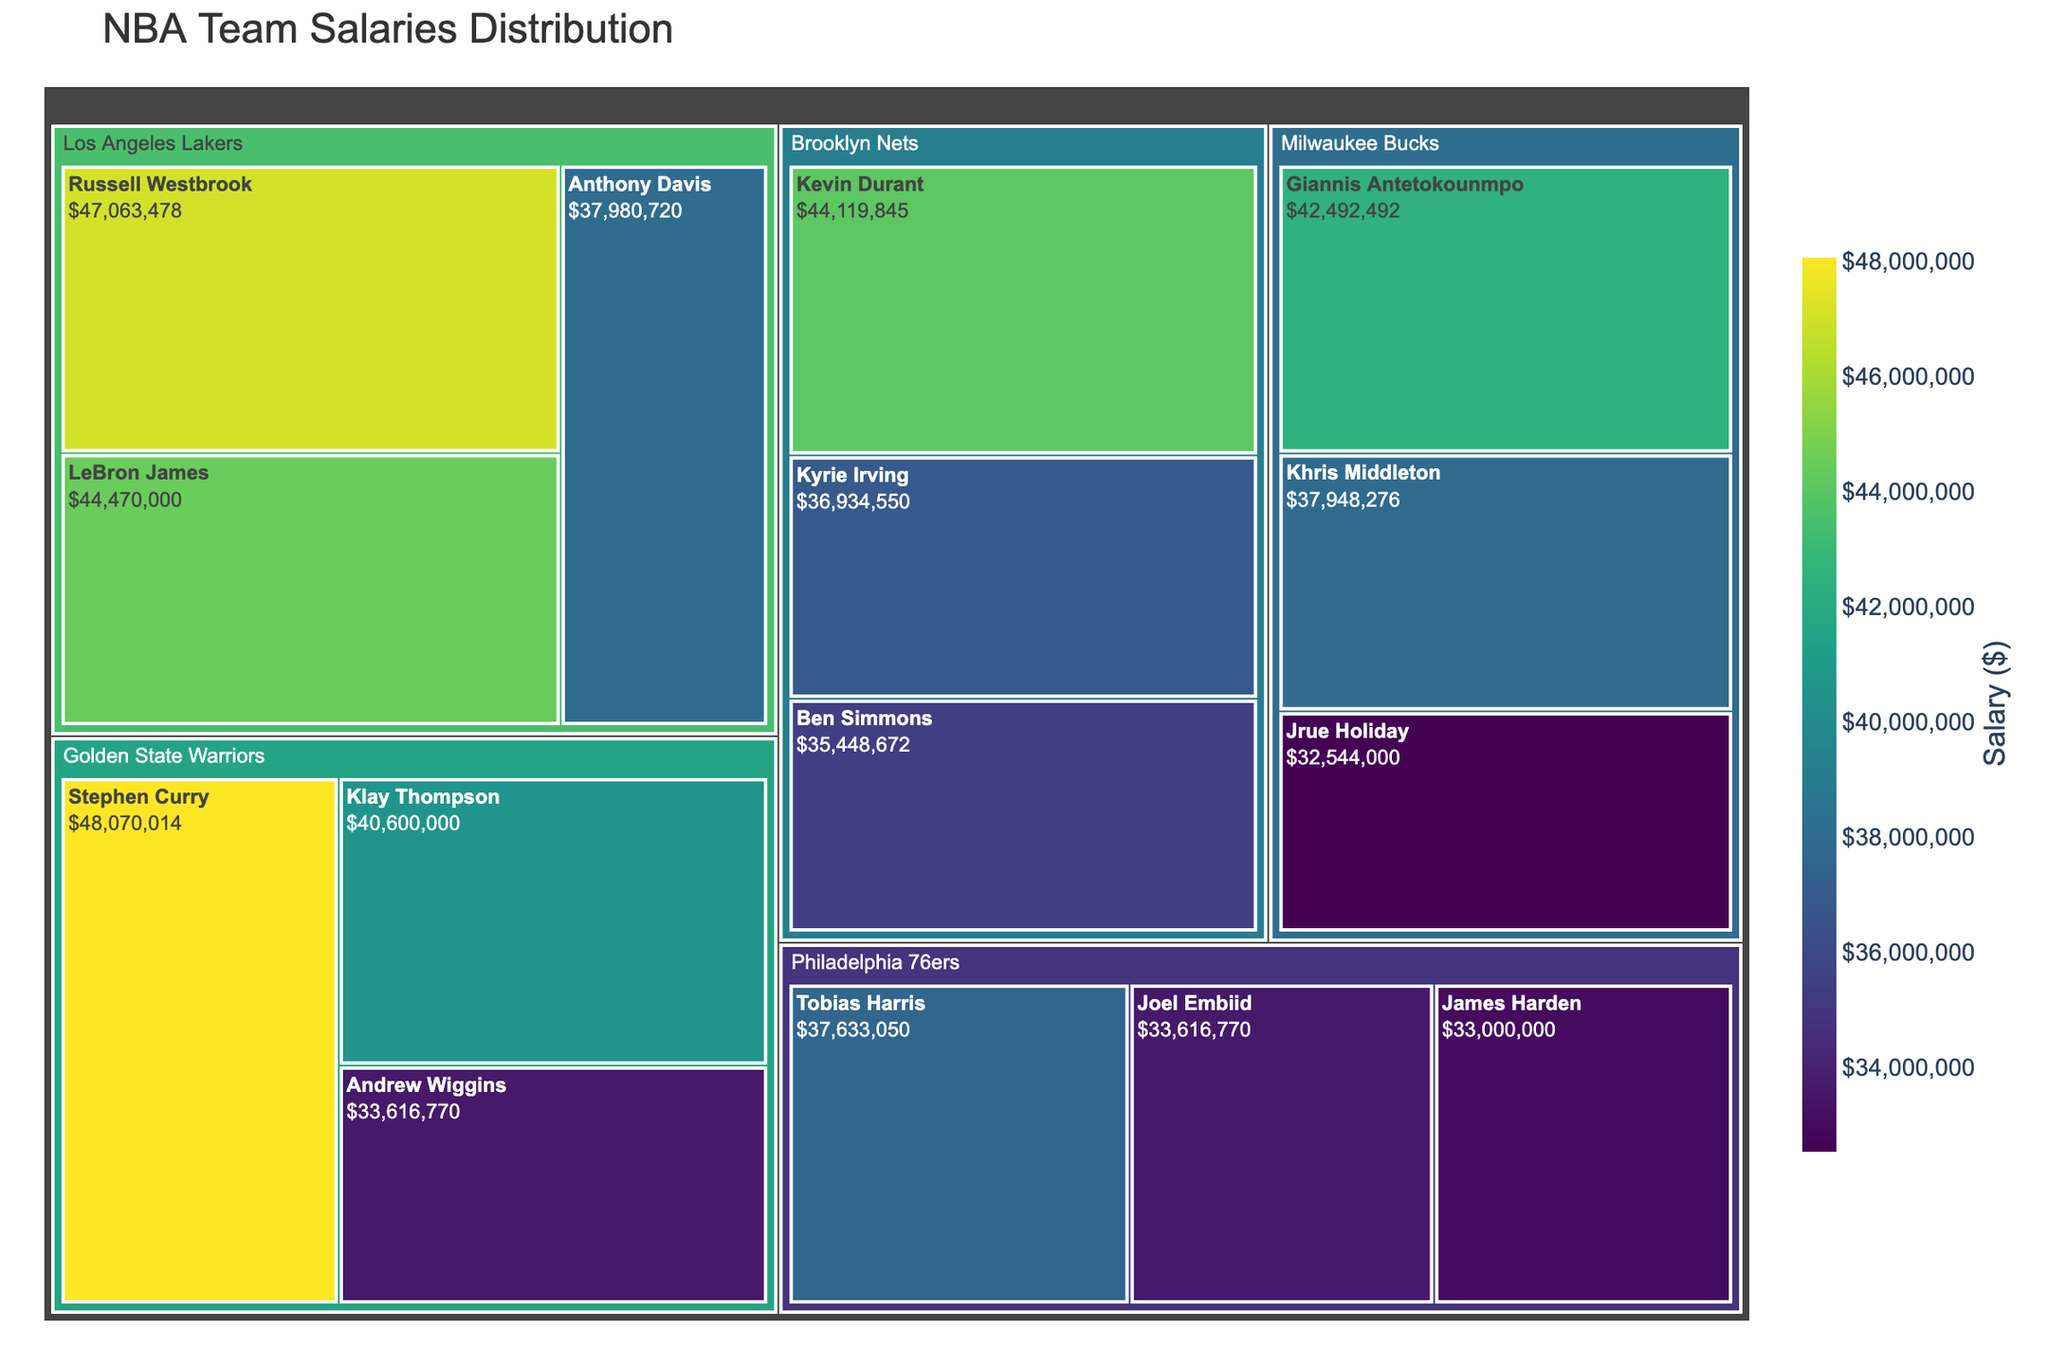what's the title of the figure? The title is typically found at the top of the figure and is meant to describe what the figure is about. In this case, it is "NBA Team Salaries Distribution".
Answer: NBA Team Salaries Distribution Which team has the player with the highest salary? To determine this, look for the largest block representing the highest salary, then identify the team associated with that player's block. Russell Westbrook from the Los Angeles Lakers has the highest salary.
Answer: Los Angeles Lakers How much is Stephen Curry's salary? Find the section in the treemap that represents Stephen Curry and look at the salary value associated with him. Stephen Curry’s salary is listed.
Answer: $48,070,014 Which player has a higher salary: LeBron James or Kevin Durant? Compare the salary values of LeBron James and Kevin Durant. LeBron James has a salary of $44,470,000, while Kevin Durant has $44,119,845.
Answer: LeBron James What is the total salary of all players on the Golden State Warriors? Add up the salaries of all the players listed under the Golden State Warriors. The sum is $48,070,014 + $40,600,000 + $33,616,770.
Answer: $122,286,784 Which player on the Milwaukee Bucks has the lowest salary? Identify the players in the Milwaukee Bucks section and compare their salaries. Jrue Holiday has the lowest salary among them.
Answer: Jrue Holiday How does the salary of Kyrie Irving compare to that of Tobias Harris? Compare the salary values for Kyrie Irving ($36,934,550) and Tobias Harris ($37,633,050). Tobias Harris's salary is slightly higher.
Answer: Tobias Harris What is the average salary of the top three highest-paid players? Identify the top three highest-paid players: Russell Westbrook, Stephen Curry, and LeBron James. Sum their salaries and divide by 3: (47,063,478 + 48,070,014 + 44,470,000) / 3.
Answer: $46,534,497 Which team has the highest total salary? Sum the salaries of each player in all teams and compare the totals. The Golden State Warriors have the highest total.
Answer: Golden State Warriors What is the salary difference between the highest-paid player and the lowest-paid player on the figure? Identify the highest-paid player (Russell Westbrook: $47,063,478) and the lowest-paid player (Jrue Holiday: $32,544,000), then calculate the difference: 47,063,478 - 32,544,000.
Answer: $14,519,478 